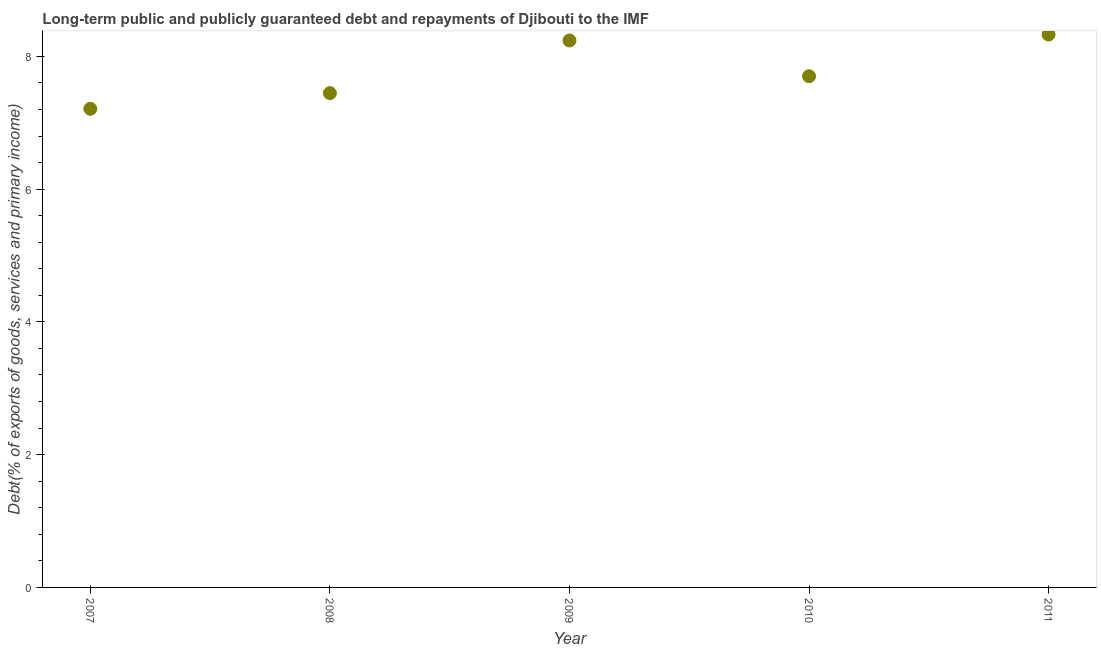What is the debt service in 2007?
Your response must be concise. 7.21. Across all years, what is the maximum debt service?
Provide a succinct answer. 8.33. Across all years, what is the minimum debt service?
Ensure brevity in your answer.  7.21. In which year was the debt service minimum?
Make the answer very short. 2007. What is the sum of the debt service?
Make the answer very short. 38.92. What is the difference between the debt service in 2007 and 2011?
Provide a succinct answer. -1.12. What is the average debt service per year?
Your answer should be compact. 7.78. What is the median debt service?
Offer a very short reply. 7.7. In how many years, is the debt service greater than 2.4 %?
Keep it short and to the point. 5. What is the ratio of the debt service in 2007 to that in 2011?
Your response must be concise. 0.87. Is the difference between the debt service in 2007 and 2011 greater than the difference between any two years?
Give a very brief answer. Yes. What is the difference between the highest and the second highest debt service?
Your response must be concise. 0.09. What is the difference between the highest and the lowest debt service?
Your answer should be compact. 1.12. In how many years, is the debt service greater than the average debt service taken over all years?
Provide a short and direct response. 2. How many dotlines are there?
Make the answer very short. 1. How many years are there in the graph?
Offer a terse response. 5. Does the graph contain grids?
Provide a short and direct response. No. What is the title of the graph?
Offer a very short reply. Long-term public and publicly guaranteed debt and repayments of Djibouti to the IMF. What is the label or title of the Y-axis?
Keep it short and to the point. Debt(% of exports of goods, services and primary income). What is the Debt(% of exports of goods, services and primary income) in 2007?
Your response must be concise. 7.21. What is the Debt(% of exports of goods, services and primary income) in 2008?
Keep it short and to the point. 7.45. What is the Debt(% of exports of goods, services and primary income) in 2009?
Provide a short and direct response. 8.24. What is the Debt(% of exports of goods, services and primary income) in 2010?
Offer a very short reply. 7.7. What is the Debt(% of exports of goods, services and primary income) in 2011?
Your response must be concise. 8.33. What is the difference between the Debt(% of exports of goods, services and primary income) in 2007 and 2008?
Your answer should be very brief. -0.24. What is the difference between the Debt(% of exports of goods, services and primary income) in 2007 and 2009?
Provide a succinct answer. -1.03. What is the difference between the Debt(% of exports of goods, services and primary income) in 2007 and 2010?
Provide a short and direct response. -0.49. What is the difference between the Debt(% of exports of goods, services and primary income) in 2007 and 2011?
Your answer should be very brief. -1.12. What is the difference between the Debt(% of exports of goods, services and primary income) in 2008 and 2009?
Offer a very short reply. -0.79. What is the difference between the Debt(% of exports of goods, services and primary income) in 2008 and 2010?
Keep it short and to the point. -0.25. What is the difference between the Debt(% of exports of goods, services and primary income) in 2008 and 2011?
Provide a succinct answer. -0.88. What is the difference between the Debt(% of exports of goods, services and primary income) in 2009 and 2010?
Your answer should be very brief. 0.54. What is the difference between the Debt(% of exports of goods, services and primary income) in 2009 and 2011?
Keep it short and to the point. -0.09. What is the difference between the Debt(% of exports of goods, services and primary income) in 2010 and 2011?
Offer a very short reply. -0.63. What is the ratio of the Debt(% of exports of goods, services and primary income) in 2007 to that in 2008?
Offer a very short reply. 0.97. What is the ratio of the Debt(% of exports of goods, services and primary income) in 2007 to that in 2010?
Your response must be concise. 0.94. What is the ratio of the Debt(% of exports of goods, services and primary income) in 2007 to that in 2011?
Provide a succinct answer. 0.87. What is the ratio of the Debt(% of exports of goods, services and primary income) in 2008 to that in 2009?
Keep it short and to the point. 0.9. What is the ratio of the Debt(% of exports of goods, services and primary income) in 2008 to that in 2011?
Provide a short and direct response. 0.89. What is the ratio of the Debt(% of exports of goods, services and primary income) in 2009 to that in 2010?
Ensure brevity in your answer.  1.07. What is the ratio of the Debt(% of exports of goods, services and primary income) in 2009 to that in 2011?
Your answer should be very brief. 0.99. What is the ratio of the Debt(% of exports of goods, services and primary income) in 2010 to that in 2011?
Your answer should be compact. 0.93. 